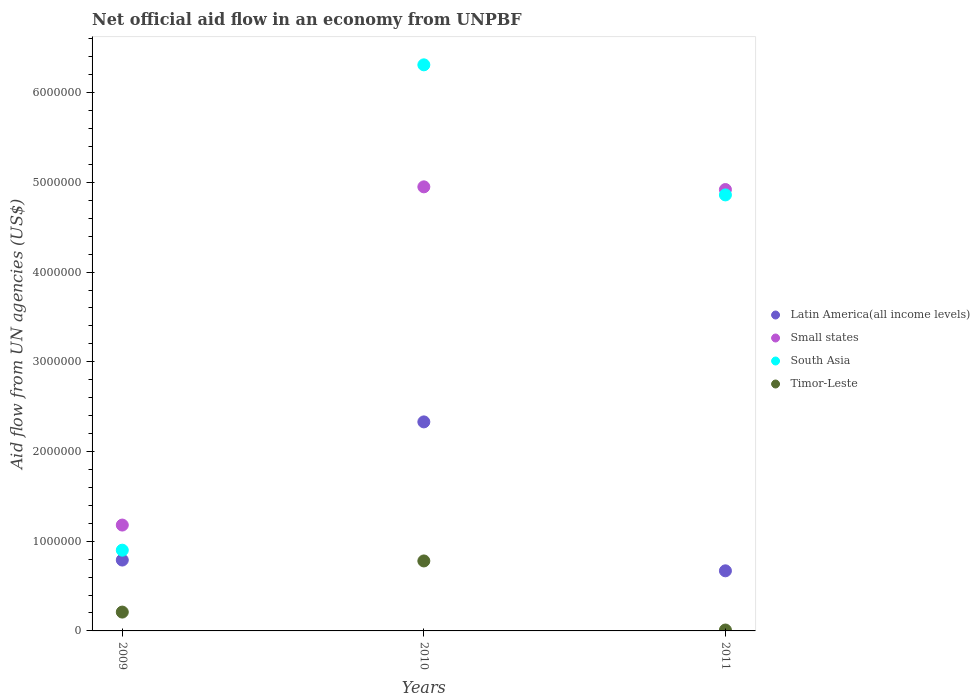How many different coloured dotlines are there?
Give a very brief answer. 4. Is the number of dotlines equal to the number of legend labels?
Provide a short and direct response. Yes. What is the net official aid flow in Latin America(all income levels) in 2010?
Make the answer very short. 2.33e+06. Across all years, what is the maximum net official aid flow in South Asia?
Provide a short and direct response. 6.31e+06. Across all years, what is the minimum net official aid flow in Small states?
Your answer should be compact. 1.18e+06. In which year was the net official aid flow in Latin America(all income levels) minimum?
Provide a short and direct response. 2011. What is the total net official aid flow in Latin America(all income levels) in the graph?
Your answer should be compact. 3.79e+06. What is the difference between the net official aid flow in Latin America(all income levels) in 2009 and that in 2010?
Your response must be concise. -1.54e+06. What is the difference between the net official aid flow in Timor-Leste in 2011 and the net official aid flow in Small states in 2010?
Your answer should be very brief. -4.94e+06. What is the average net official aid flow in Small states per year?
Provide a short and direct response. 3.68e+06. In the year 2010, what is the difference between the net official aid flow in Timor-Leste and net official aid flow in Small states?
Provide a short and direct response. -4.17e+06. What is the difference between the highest and the second highest net official aid flow in Latin America(all income levels)?
Ensure brevity in your answer.  1.54e+06. What is the difference between the highest and the lowest net official aid flow in Small states?
Your response must be concise. 3.77e+06. In how many years, is the net official aid flow in Small states greater than the average net official aid flow in Small states taken over all years?
Offer a very short reply. 2. Is the sum of the net official aid flow in Small states in 2009 and 2011 greater than the maximum net official aid flow in South Asia across all years?
Ensure brevity in your answer.  No. Is it the case that in every year, the sum of the net official aid flow in Small states and net official aid flow in Latin America(all income levels)  is greater than the sum of net official aid flow in South Asia and net official aid flow in Timor-Leste?
Ensure brevity in your answer.  No. Does the net official aid flow in Latin America(all income levels) monotonically increase over the years?
Your answer should be very brief. No. Is the net official aid flow in Small states strictly greater than the net official aid flow in Timor-Leste over the years?
Make the answer very short. Yes. Is the net official aid flow in South Asia strictly less than the net official aid flow in Small states over the years?
Your answer should be compact. No. How many dotlines are there?
Give a very brief answer. 4. How many years are there in the graph?
Make the answer very short. 3. What is the difference between two consecutive major ticks on the Y-axis?
Keep it short and to the point. 1.00e+06. Are the values on the major ticks of Y-axis written in scientific E-notation?
Give a very brief answer. No. Does the graph contain any zero values?
Offer a terse response. No. How many legend labels are there?
Your response must be concise. 4. What is the title of the graph?
Keep it short and to the point. Net official aid flow in an economy from UNPBF. Does "Mauritania" appear as one of the legend labels in the graph?
Provide a succinct answer. No. What is the label or title of the X-axis?
Provide a short and direct response. Years. What is the label or title of the Y-axis?
Provide a short and direct response. Aid flow from UN agencies (US$). What is the Aid flow from UN agencies (US$) in Latin America(all income levels) in 2009?
Offer a very short reply. 7.90e+05. What is the Aid flow from UN agencies (US$) in Small states in 2009?
Make the answer very short. 1.18e+06. What is the Aid flow from UN agencies (US$) of South Asia in 2009?
Offer a terse response. 9.00e+05. What is the Aid flow from UN agencies (US$) in Timor-Leste in 2009?
Give a very brief answer. 2.10e+05. What is the Aid flow from UN agencies (US$) of Latin America(all income levels) in 2010?
Your response must be concise. 2.33e+06. What is the Aid flow from UN agencies (US$) of Small states in 2010?
Make the answer very short. 4.95e+06. What is the Aid flow from UN agencies (US$) in South Asia in 2010?
Offer a terse response. 6.31e+06. What is the Aid flow from UN agencies (US$) of Timor-Leste in 2010?
Make the answer very short. 7.80e+05. What is the Aid flow from UN agencies (US$) in Latin America(all income levels) in 2011?
Ensure brevity in your answer.  6.70e+05. What is the Aid flow from UN agencies (US$) in Small states in 2011?
Provide a succinct answer. 4.92e+06. What is the Aid flow from UN agencies (US$) in South Asia in 2011?
Your response must be concise. 4.86e+06. What is the Aid flow from UN agencies (US$) in Timor-Leste in 2011?
Your answer should be compact. 10000. Across all years, what is the maximum Aid flow from UN agencies (US$) in Latin America(all income levels)?
Make the answer very short. 2.33e+06. Across all years, what is the maximum Aid flow from UN agencies (US$) of Small states?
Ensure brevity in your answer.  4.95e+06. Across all years, what is the maximum Aid flow from UN agencies (US$) in South Asia?
Ensure brevity in your answer.  6.31e+06. Across all years, what is the maximum Aid flow from UN agencies (US$) in Timor-Leste?
Your response must be concise. 7.80e+05. Across all years, what is the minimum Aid flow from UN agencies (US$) of Latin America(all income levels)?
Ensure brevity in your answer.  6.70e+05. Across all years, what is the minimum Aid flow from UN agencies (US$) in Small states?
Give a very brief answer. 1.18e+06. Across all years, what is the minimum Aid flow from UN agencies (US$) in Timor-Leste?
Your answer should be very brief. 10000. What is the total Aid flow from UN agencies (US$) of Latin America(all income levels) in the graph?
Give a very brief answer. 3.79e+06. What is the total Aid flow from UN agencies (US$) in Small states in the graph?
Offer a terse response. 1.10e+07. What is the total Aid flow from UN agencies (US$) of South Asia in the graph?
Offer a terse response. 1.21e+07. What is the difference between the Aid flow from UN agencies (US$) in Latin America(all income levels) in 2009 and that in 2010?
Your answer should be compact. -1.54e+06. What is the difference between the Aid flow from UN agencies (US$) of Small states in 2009 and that in 2010?
Offer a terse response. -3.77e+06. What is the difference between the Aid flow from UN agencies (US$) of South Asia in 2009 and that in 2010?
Your answer should be compact. -5.41e+06. What is the difference between the Aid flow from UN agencies (US$) of Timor-Leste in 2009 and that in 2010?
Keep it short and to the point. -5.70e+05. What is the difference between the Aid flow from UN agencies (US$) in Small states in 2009 and that in 2011?
Provide a short and direct response. -3.74e+06. What is the difference between the Aid flow from UN agencies (US$) in South Asia in 2009 and that in 2011?
Keep it short and to the point. -3.96e+06. What is the difference between the Aid flow from UN agencies (US$) of Latin America(all income levels) in 2010 and that in 2011?
Keep it short and to the point. 1.66e+06. What is the difference between the Aid flow from UN agencies (US$) of Small states in 2010 and that in 2011?
Offer a terse response. 3.00e+04. What is the difference between the Aid flow from UN agencies (US$) in South Asia in 2010 and that in 2011?
Your answer should be compact. 1.45e+06. What is the difference between the Aid flow from UN agencies (US$) in Timor-Leste in 2010 and that in 2011?
Offer a terse response. 7.70e+05. What is the difference between the Aid flow from UN agencies (US$) of Latin America(all income levels) in 2009 and the Aid flow from UN agencies (US$) of Small states in 2010?
Provide a succinct answer. -4.16e+06. What is the difference between the Aid flow from UN agencies (US$) in Latin America(all income levels) in 2009 and the Aid flow from UN agencies (US$) in South Asia in 2010?
Give a very brief answer. -5.52e+06. What is the difference between the Aid flow from UN agencies (US$) of Latin America(all income levels) in 2009 and the Aid flow from UN agencies (US$) of Timor-Leste in 2010?
Make the answer very short. 10000. What is the difference between the Aid flow from UN agencies (US$) in Small states in 2009 and the Aid flow from UN agencies (US$) in South Asia in 2010?
Your answer should be very brief. -5.13e+06. What is the difference between the Aid flow from UN agencies (US$) of South Asia in 2009 and the Aid flow from UN agencies (US$) of Timor-Leste in 2010?
Keep it short and to the point. 1.20e+05. What is the difference between the Aid flow from UN agencies (US$) in Latin America(all income levels) in 2009 and the Aid flow from UN agencies (US$) in Small states in 2011?
Your answer should be very brief. -4.13e+06. What is the difference between the Aid flow from UN agencies (US$) of Latin America(all income levels) in 2009 and the Aid flow from UN agencies (US$) of South Asia in 2011?
Keep it short and to the point. -4.07e+06. What is the difference between the Aid flow from UN agencies (US$) in Latin America(all income levels) in 2009 and the Aid flow from UN agencies (US$) in Timor-Leste in 2011?
Your answer should be very brief. 7.80e+05. What is the difference between the Aid flow from UN agencies (US$) of Small states in 2009 and the Aid flow from UN agencies (US$) of South Asia in 2011?
Your answer should be compact. -3.68e+06. What is the difference between the Aid flow from UN agencies (US$) in Small states in 2009 and the Aid flow from UN agencies (US$) in Timor-Leste in 2011?
Your answer should be compact. 1.17e+06. What is the difference between the Aid flow from UN agencies (US$) in South Asia in 2009 and the Aid flow from UN agencies (US$) in Timor-Leste in 2011?
Provide a short and direct response. 8.90e+05. What is the difference between the Aid flow from UN agencies (US$) in Latin America(all income levels) in 2010 and the Aid flow from UN agencies (US$) in Small states in 2011?
Provide a short and direct response. -2.59e+06. What is the difference between the Aid flow from UN agencies (US$) in Latin America(all income levels) in 2010 and the Aid flow from UN agencies (US$) in South Asia in 2011?
Ensure brevity in your answer.  -2.53e+06. What is the difference between the Aid flow from UN agencies (US$) of Latin America(all income levels) in 2010 and the Aid flow from UN agencies (US$) of Timor-Leste in 2011?
Your answer should be compact. 2.32e+06. What is the difference between the Aid flow from UN agencies (US$) of Small states in 2010 and the Aid flow from UN agencies (US$) of South Asia in 2011?
Your answer should be compact. 9.00e+04. What is the difference between the Aid flow from UN agencies (US$) in Small states in 2010 and the Aid flow from UN agencies (US$) in Timor-Leste in 2011?
Make the answer very short. 4.94e+06. What is the difference between the Aid flow from UN agencies (US$) of South Asia in 2010 and the Aid flow from UN agencies (US$) of Timor-Leste in 2011?
Keep it short and to the point. 6.30e+06. What is the average Aid flow from UN agencies (US$) of Latin America(all income levels) per year?
Give a very brief answer. 1.26e+06. What is the average Aid flow from UN agencies (US$) of Small states per year?
Your response must be concise. 3.68e+06. What is the average Aid flow from UN agencies (US$) of South Asia per year?
Give a very brief answer. 4.02e+06. What is the average Aid flow from UN agencies (US$) of Timor-Leste per year?
Offer a very short reply. 3.33e+05. In the year 2009, what is the difference between the Aid flow from UN agencies (US$) in Latin America(all income levels) and Aid flow from UN agencies (US$) in Small states?
Keep it short and to the point. -3.90e+05. In the year 2009, what is the difference between the Aid flow from UN agencies (US$) of Latin America(all income levels) and Aid flow from UN agencies (US$) of South Asia?
Give a very brief answer. -1.10e+05. In the year 2009, what is the difference between the Aid flow from UN agencies (US$) of Latin America(all income levels) and Aid flow from UN agencies (US$) of Timor-Leste?
Make the answer very short. 5.80e+05. In the year 2009, what is the difference between the Aid flow from UN agencies (US$) of Small states and Aid flow from UN agencies (US$) of South Asia?
Give a very brief answer. 2.80e+05. In the year 2009, what is the difference between the Aid flow from UN agencies (US$) of Small states and Aid flow from UN agencies (US$) of Timor-Leste?
Your response must be concise. 9.70e+05. In the year 2009, what is the difference between the Aid flow from UN agencies (US$) of South Asia and Aid flow from UN agencies (US$) of Timor-Leste?
Your answer should be very brief. 6.90e+05. In the year 2010, what is the difference between the Aid flow from UN agencies (US$) in Latin America(all income levels) and Aid flow from UN agencies (US$) in Small states?
Give a very brief answer. -2.62e+06. In the year 2010, what is the difference between the Aid flow from UN agencies (US$) in Latin America(all income levels) and Aid flow from UN agencies (US$) in South Asia?
Give a very brief answer. -3.98e+06. In the year 2010, what is the difference between the Aid flow from UN agencies (US$) of Latin America(all income levels) and Aid flow from UN agencies (US$) of Timor-Leste?
Make the answer very short. 1.55e+06. In the year 2010, what is the difference between the Aid flow from UN agencies (US$) in Small states and Aid flow from UN agencies (US$) in South Asia?
Make the answer very short. -1.36e+06. In the year 2010, what is the difference between the Aid flow from UN agencies (US$) in Small states and Aid flow from UN agencies (US$) in Timor-Leste?
Your answer should be very brief. 4.17e+06. In the year 2010, what is the difference between the Aid flow from UN agencies (US$) of South Asia and Aid flow from UN agencies (US$) of Timor-Leste?
Your answer should be very brief. 5.53e+06. In the year 2011, what is the difference between the Aid flow from UN agencies (US$) of Latin America(all income levels) and Aid flow from UN agencies (US$) of Small states?
Provide a succinct answer. -4.25e+06. In the year 2011, what is the difference between the Aid flow from UN agencies (US$) in Latin America(all income levels) and Aid flow from UN agencies (US$) in South Asia?
Give a very brief answer. -4.19e+06. In the year 2011, what is the difference between the Aid flow from UN agencies (US$) in Latin America(all income levels) and Aid flow from UN agencies (US$) in Timor-Leste?
Give a very brief answer. 6.60e+05. In the year 2011, what is the difference between the Aid flow from UN agencies (US$) of Small states and Aid flow from UN agencies (US$) of South Asia?
Give a very brief answer. 6.00e+04. In the year 2011, what is the difference between the Aid flow from UN agencies (US$) of Small states and Aid flow from UN agencies (US$) of Timor-Leste?
Make the answer very short. 4.91e+06. In the year 2011, what is the difference between the Aid flow from UN agencies (US$) of South Asia and Aid flow from UN agencies (US$) of Timor-Leste?
Give a very brief answer. 4.85e+06. What is the ratio of the Aid flow from UN agencies (US$) in Latin America(all income levels) in 2009 to that in 2010?
Make the answer very short. 0.34. What is the ratio of the Aid flow from UN agencies (US$) in Small states in 2009 to that in 2010?
Your answer should be compact. 0.24. What is the ratio of the Aid flow from UN agencies (US$) in South Asia in 2009 to that in 2010?
Ensure brevity in your answer.  0.14. What is the ratio of the Aid flow from UN agencies (US$) of Timor-Leste in 2009 to that in 2010?
Make the answer very short. 0.27. What is the ratio of the Aid flow from UN agencies (US$) in Latin America(all income levels) in 2009 to that in 2011?
Make the answer very short. 1.18. What is the ratio of the Aid flow from UN agencies (US$) in Small states in 2009 to that in 2011?
Your response must be concise. 0.24. What is the ratio of the Aid flow from UN agencies (US$) in South Asia in 2009 to that in 2011?
Make the answer very short. 0.19. What is the ratio of the Aid flow from UN agencies (US$) in Timor-Leste in 2009 to that in 2011?
Offer a terse response. 21. What is the ratio of the Aid flow from UN agencies (US$) in Latin America(all income levels) in 2010 to that in 2011?
Your response must be concise. 3.48. What is the ratio of the Aid flow from UN agencies (US$) of South Asia in 2010 to that in 2011?
Your answer should be compact. 1.3. What is the ratio of the Aid flow from UN agencies (US$) of Timor-Leste in 2010 to that in 2011?
Offer a very short reply. 78. What is the difference between the highest and the second highest Aid flow from UN agencies (US$) in Latin America(all income levels)?
Ensure brevity in your answer.  1.54e+06. What is the difference between the highest and the second highest Aid flow from UN agencies (US$) of Small states?
Your answer should be compact. 3.00e+04. What is the difference between the highest and the second highest Aid flow from UN agencies (US$) in South Asia?
Provide a short and direct response. 1.45e+06. What is the difference between the highest and the second highest Aid flow from UN agencies (US$) of Timor-Leste?
Make the answer very short. 5.70e+05. What is the difference between the highest and the lowest Aid flow from UN agencies (US$) in Latin America(all income levels)?
Your answer should be very brief. 1.66e+06. What is the difference between the highest and the lowest Aid flow from UN agencies (US$) of Small states?
Ensure brevity in your answer.  3.77e+06. What is the difference between the highest and the lowest Aid flow from UN agencies (US$) of South Asia?
Make the answer very short. 5.41e+06. What is the difference between the highest and the lowest Aid flow from UN agencies (US$) of Timor-Leste?
Keep it short and to the point. 7.70e+05. 